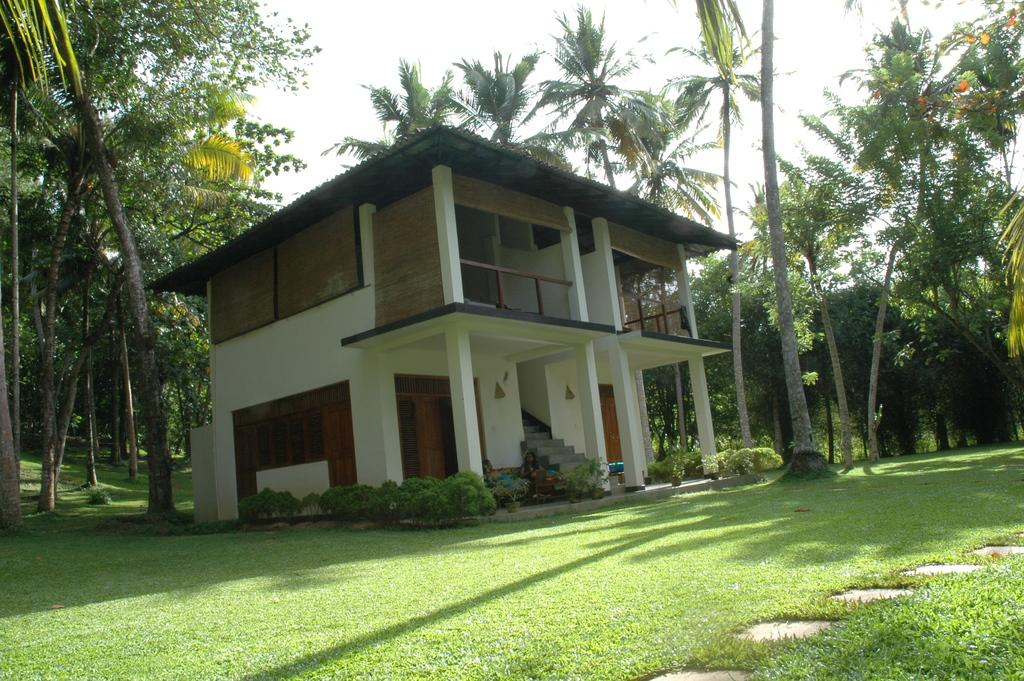What type of vegetation is present in the image? There is grass in the image. What architectural feature can be seen in the image? There are stairs in the image. What is the color of the building in the image? The building in the image is white-colored. What can be observed due to the presence of sunlight in the image? Shadows are visible in the image. What other natural elements are present in the image? There are trees in the image. What type of net is being used for war in the image? There is no net or war depicted in the image; it features grass, stairs, a white-colored building, shadows, and trees. 